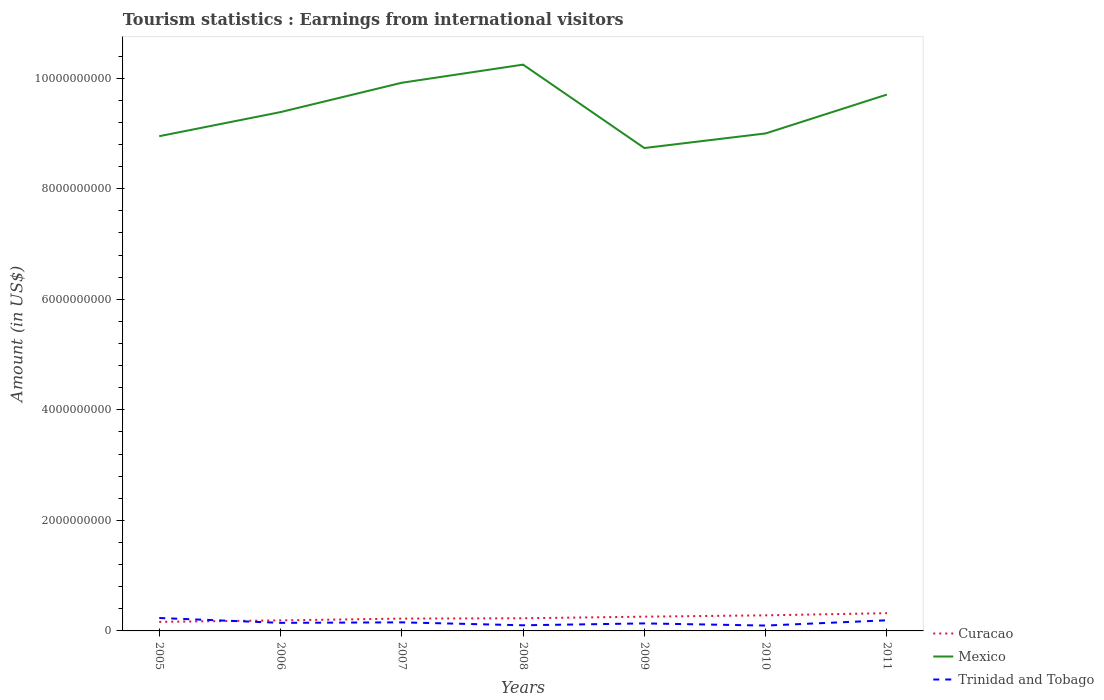Across all years, what is the maximum earnings from international visitors in Trinidad and Tobago?
Provide a succinct answer. 9.70e+07. What is the total earnings from international visitors in Curacao in the graph?
Your answer should be very brief. -9.20e+07. What is the difference between the highest and the second highest earnings from international visitors in Trinidad and Tobago?
Ensure brevity in your answer.  1.37e+08. What is the difference between the highest and the lowest earnings from international visitors in Trinidad and Tobago?
Provide a short and direct response. 3. What is the difference between two consecutive major ticks on the Y-axis?
Provide a succinct answer. 2.00e+09. Does the graph contain any zero values?
Provide a succinct answer. No. How many legend labels are there?
Make the answer very short. 3. How are the legend labels stacked?
Make the answer very short. Vertical. What is the title of the graph?
Your answer should be compact. Tourism statistics : Earnings from international visitors. Does "Sierra Leone" appear as one of the legend labels in the graph?
Make the answer very short. No. What is the label or title of the X-axis?
Offer a very short reply. Years. What is the label or title of the Y-axis?
Offer a terse response. Amount (in US$). What is the Amount (in US$) in Curacao in 2005?
Provide a succinct answer. 1.64e+08. What is the Amount (in US$) in Mexico in 2005?
Make the answer very short. 8.95e+09. What is the Amount (in US$) in Trinidad and Tobago in 2005?
Provide a short and direct response. 2.34e+08. What is the Amount (in US$) of Curacao in 2006?
Your answer should be compact. 1.91e+08. What is the Amount (in US$) in Mexico in 2006?
Your response must be concise. 9.39e+09. What is the Amount (in US$) in Trinidad and Tobago in 2006?
Offer a terse response. 1.46e+08. What is the Amount (in US$) in Curacao in 2007?
Keep it short and to the point. 2.23e+08. What is the Amount (in US$) of Mexico in 2007?
Your answer should be very brief. 9.92e+09. What is the Amount (in US$) of Trinidad and Tobago in 2007?
Your answer should be very brief. 1.55e+08. What is the Amount (in US$) of Curacao in 2008?
Offer a terse response. 2.29e+08. What is the Amount (in US$) of Mexico in 2008?
Offer a very short reply. 1.02e+1. What is the Amount (in US$) in Trinidad and Tobago in 2008?
Your response must be concise. 1.02e+08. What is the Amount (in US$) in Curacao in 2009?
Your answer should be compact. 2.58e+08. What is the Amount (in US$) of Mexico in 2009?
Provide a succinct answer. 8.74e+09. What is the Amount (in US$) of Trinidad and Tobago in 2009?
Offer a very short reply. 1.36e+08. What is the Amount (in US$) of Curacao in 2010?
Your answer should be very brief. 2.82e+08. What is the Amount (in US$) in Mexico in 2010?
Make the answer very short. 9.00e+09. What is the Amount (in US$) of Trinidad and Tobago in 2010?
Make the answer very short. 9.70e+07. What is the Amount (in US$) in Curacao in 2011?
Ensure brevity in your answer.  3.21e+08. What is the Amount (in US$) in Mexico in 2011?
Keep it short and to the point. 9.70e+09. What is the Amount (in US$) in Trinidad and Tobago in 2011?
Your answer should be compact. 1.92e+08. Across all years, what is the maximum Amount (in US$) in Curacao?
Offer a terse response. 3.21e+08. Across all years, what is the maximum Amount (in US$) of Mexico?
Make the answer very short. 1.02e+1. Across all years, what is the maximum Amount (in US$) of Trinidad and Tobago?
Keep it short and to the point. 2.34e+08. Across all years, what is the minimum Amount (in US$) in Curacao?
Offer a terse response. 1.64e+08. Across all years, what is the minimum Amount (in US$) of Mexico?
Provide a short and direct response. 8.74e+09. Across all years, what is the minimum Amount (in US$) of Trinidad and Tobago?
Offer a very short reply. 9.70e+07. What is the total Amount (in US$) in Curacao in the graph?
Ensure brevity in your answer.  1.67e+09. What is the total Amount (in US$) in Mexico in the graph?
Offer a very short reply. 6.59e+1. What is the total Amount (in US$) of Trinidad and Tobago in the graph?
Your answer should be compact. 1.06e+09. What is the difference between the Amount (in US$) in Curacao in 2005 and that in 2006?
Provide a succinct answer. -2.70e+07. What is the difference between the Amount (in US$) in Mexico in 2005 and that in 2006?
Your response must be concise. -4.36e+08. What is the difference between the Amount (in US$) of Trinidad and Tobago in 2005 and that in 2006?
Provide a short and direct response. 8.80e+07. What is the difference between the Amount (in US$) of Curacao in 2005 and that in 2007?
Your response must be concise. -5.90e+07. What is the difference between the Amount (in US$) of Mexico in 2005 and that in 2007?
Your answer should be very brief. -9.67e+08. What is the difference between the Amount (in US$) in Trinidad and Tobago in 2005 and that in 2007?
Provide a short and direct response. 7.90e+07. What is the difference between the Amount (in US$) of Curacao in 2005 and that in 2008?
Provide a short and direct response. -6.50e+07. What is the difference between the Amount (in US$) of Mexico in 2005 and that in 2008?
Keep it short and to the point. -1.30e+09. What is the difference between the Amount (in US$) of Trinidad and Tobago in 2005 and that in 2008?
Give a very brief answer. 1.32e+08. What is the difference between the Amount (in US$) of Curacao in 2005 and that in 2009?
Provide a short and direct response. -9.40e+07. What is the difference between the Amount (in US$) in Mexico in 2005 and that in 2009?
Offer a terse response. 2.14e+08. What is the difference between the Amount (in US$) of Trinidad and Tobago in 2005 and that in 2009?
Provide a succinct answer. 9.80e+07. What is the difference between the Amount (in US$) of Curacao in 2005 and that in 2010?
Keep it short and to the point. -1.18e+08. What is the difference between the Amount (in US$) of Mexico in 2005 and that in 2010?
Provide a short and direct response. -5.00e+07. What is the difference between the Amount (in US$) in Trinidad and Tobago in 2005 and that in 2010?
Offer a very short reply. 1.37e+08. What is the difference between the Amount (in US$) of Curacao in 2005 and that in 2011?
Ensure brevity in your answer.  -1.57e+08. What is the difference between the Amount (in US$) of Mexico in 2005 and that in 2011?
Ensure brevity in your answer.  -7.53e+08. What is the difference between the Amount (in US$) of Trinidad and Tobago in 2005 and that in 2011?
Offer a very short reply. 4.20e+07. What is the difference between the Amount (in US$) of Curacao in 2006 and that in 2007?
Your response must be concise. -3.20e+07. What is the difference between the Amount (in US$) in Mexico in 2006 and that in 2007?
Offer a very short reply. -5.31e+08. What is the difference between the Amount (in US$) of Trinidad and Tobago in 2006 and that in 2007?
Make the answer very short. -9.00e+06. What is the difference between the Amount (in US$) of Curacao in 2006 and that in 2008?
Ensure brevity in your answer.  -3.80e+07. What is the difference between the Amount (in US$) of Mexico in 2006 and that in 2008?
Give a very brief answer. -8.59e+08. What is the difference between the Amount (in US$) in Trinidad and Tobago in 2006 and that in 2008?
Offer a terse response. 4.40e+07. What is the difference between the Amount (in US$) in Curacao in 2006 and that in 2009?
Provide a short and direct response. -6.70e+07. What is the difference between the Amount (in US$) of Mexico in 2006 and that in 2009?
Your answer should be compact. 6.50e+08. What is the difference between the Amount (in US$) of Curacao in 2006 and that in 2010?
Provide a succinct answer. -9.10e+07. What is the difference between the Amount (in US$) in Mexico in 2006 and that in 2010?
Make the answer very short. 3.86e+08. What is the difference between the Amount (in US$) in Trinidad and Tobago in 2006 and that in 2010?
Your answer should be compact. 4.90e+07. What is the difference between the Amount (in US$) of Curacao in 2006 and that in 2011?
Your answer should be very brief. -1.30e+08. What is the difference between the Amount (in US$) in Mexico in 2006 and that in 2011?
Offer a terse response. -3.17e+08. What is the difference between the Amount (in US$) in Trinidad and Tobago in 2006 and that in 2011?
Ensure brevity in your answer.  -4.60e+07. What is the difference between the Amount (in US$) of Curacao in 2007 and that in 2008?
Your response must be concise. -6.00e+06. What is the difference between the Amount (in US$) in Mexico in 2007 and that in 2008?
Ensure brevity in your answer.  -3.28e+08. What is the difference between the Amount (in US$) in Trinidad and Tobago in 2007 and that in 2008?
Your answer should be compact. 5.30e+07. What is the difference between the Amount (in US$) of Curacao in 2007 and that in 2009?
Your answer should be compact. -3.50e+07. What is the difference between the Amount (in US$) in Mexico in 2007 and that in 2009?
Offer a very short reply. 1.18e+09. What is the difference between the Amount (in US$) in Trinidad and Tobago in 2007 and that in 2009?
Make the answer very short. 1.90e+07. What is the difference between the Amount (in US$) in Curacao in 2007 and that in 2010?
Make the answer very short. -5.90e+07. What is the difference between the Amount (in US$) in Mexico in 2007 and that in 2010?
Give a very brief answer. 9.17e+08. What is the difference between the Amount (in US$) of Trinidad and Tobago in 2007 and that in 2010?
Provide a succinct answer. 5.80e+07. What is the difference between the Amount (in US$) in Curacao in 2007 and that in 2011?
Offer a terse response. -9.80e+07. What is the difference between the Amount (in US$) in Mexico in 2007 and that in 2011?
Keep it short and to the point. 2.14e+08. What is the difference between the Amount (in US$) of Trinidad and Tobago in 2007 and that in 2011?
Give a very brief answer. -3.70e+07. What is the difference between the Amount (in US$) in Curacao in 2008 and that in 2009?
Make the answer very short. -2.90e+07. What is the difference between the Amount (in US$) of Mexico in 2008 and that in 2009?
Your answer should be very brief. 1.51e+09. What is the difference between the Amount (in US$) in Trinidad and Tobago in 2008 and that in 2009?
Offer a very short reply. -3.40e+07. What is the difference between the Amount (in US$) in Curacao in 2008 and that in 2010?
Keep it short and to the point. -5.30e+07. What is the difference between the Amount (in US$) of Mexico in 2008 and that in 2010?
Provide a short and direct response. 1.24e+09. What is the difference between the Amount (in US$) of Trinidad and Tobago in 2008 and that in 2010?
Ensure brevity in your answer.  5.00e+06. What is the difference between the Amount (in US$) of Curacao in 2008 and that in 2011?
Your answer should be very brief. -9.20e+07. What is the difference between the Amount (in US$) in Mexico in 2008 and that in 2011?
Your response must be concise. 5.42e+08. What is the difference between the Amount (in US$) in Trinidad and Tobago in 2008 and that in 2011?
Keep it short and to the point. -9.00e+07. What is the difference between the Amount (in US$) in Curacao in 2009 and that in 2010?
Ensure brevity in your answer.  -2.40e+07. What is the difference between the Amount (in US$) in Mexico in 2009 and that in 2010?
Keep it short and to the point. -2.64e+08. What is the difference between the Amount (in US$) of Trinidad and Tobago in 2009 and that in 2010?
Your answer should be very brief. 3.90e+07. What is the difference between the Amount (in US$) of Curacao in 2009 and that in 2011?
Ensure brevity in your answer.  -6.30e+07. What is the difference between the Amount (in US$) in Mexico in 2009 and that in 2011?
Provide a short and direct response. -9.67e+08. What is the difference between the Amount (in US$) in Trinidad and Tobago in 2009 and that in 2011?
Offer a very short reply. -5.60e+07. What is the difference between the Amount (in US$) in Curacao in 2010 and that in 2011?
Keep it short and to the point. -3.90e+07. What is the difference between the Amount (in US$) of Mexico in 2010 and that in 2011?
Ensure brevity in your answer.  -7.03e+08. What is the difference between the Amount (in US$) of Trinidad and Tobago in 2010 and that in 2011?
Your answer should be compact. -9.50e+07. What is the difference between the Amount (in US$) of Curacao in 2005 and the Amount (in US$) of Mexico in 2006?
Your response must be concise. -9.22e+09. What is the difference between the Amount (in US$) of Curacao in 2005 and the Amount (in US$) of Trinidad and Tobago in 2006?
Your answer should be very brief. 1.80e+07. What is the difference between the Amount (in US$) of Mexico in 2005 and the Amount (in US$) of Trinidad and Tobago in 2006?
Make the answer very short. 8.80e+09. What is the difference between the Amount (in US$) in Curacao in 2005 and the Amount (in US$) in Mexico in 2007?
Provide a short and direct response. -9.75e+09. What is the difference between the Amount (in US$) in Curacao in 2005 and the Amount (in US$) in Trinidad and Tobago in 2007?
Make the answer very short. 9.00e+06. What is the difference between the Amount (in US$) of Mexico in 2005 and the Amount (in US$) of Trinidad and Tobago in 2007?
Keep it short and to the point. 8.80e+09. What is the difference between the Amount (in US$) of Curacao in 2005 and the Amount (in US$) of Mexico in 2008?
Ensure brevity in your answer.  -1.01e+1. What is the difference between the Amount (in US$) in Curacao in 2005 and the Amount (in US$) in Trinidad and Tobago in 2008?
Give a very brief answer. 6.20e+07. What is the difference between the Amount (in US$) in Mexico in 2005 and the Amount (in US$) in Trinidad and Tobago in 2008?
Make the answer very short. 8.85e+09. What is the difference between the Amount (in US$) of Curacao in 2005 and the Amount (in US$) of Mexico in 2009?
Keep it short and to the point. -8.57e+09. What is the difference between the Amount (in US$) in Curacao in 2005 and the Amount (in US$) in Trinidad and Tobago in 2009?
Offer a terse response. 2.80e+07. What is the difference between the Amount (in US$) of Mexico in 2005 and the Amount (in US$) of Trinidad and Tobago in 2009?
Give a very brief answer. 8.82e+09. What is the difference between the Amount (in US$) in Curacao in 2005 and the Amount (in US$) in Mexico in 2010?
Give a very brief answer. -8.84e+09. What is the difference between the Amount (in US$) of Curacao in 2005 and the Amount (in US$) of Trinidad and Tobago in 2010?
Offer a terse response. 6.70e+07. What is the difference between the Amount (in US$) in Mexico in 2005 and the Amount (in US$) in Trinidad and Tobago in 2010?
Provide a short and direct response. 8.85e+09. What is the difference between the Amount (in US$) in Curacao in 2005 and the Amount (in US$) in Mexico in 2011?
Make the answer very short. -9.54e+09. What is the difference between the Amount (in US$) in Curacao in 2005 and the Amount (in US$) in Trinidad and Tobago in 2011?
Your answer should be compact. -2.80e+07. What is the difference between the Amount (in US$) in Mexico in 2005 and the Amount (in US$) in Trinidad and Tobago in 2011?
Keep it short and to the point. 8.76e+09. What is the difference between the Amount (in US$) in Curacao in 2006 and the Amount (in US$) in Mexico in 2007?
Offer a very short reply. -9.73e+09. What is the difference between the Amount (in US$) of Curacao in 2006 and the Amount (in US$) of Trinidad and Tobago in 2007?
Make the answer very short. 3.60e+07. What is the difference between the Amount (in US$) in Mexico in 2006 and the Amount (in US$) in Trinidad and Tobago in 2007?
Ensure brevity in your answer.  9.23e+09. What is the difference between the Amount (in US$) of Curacao in 2006 and the Amount (in US$) of Mexico in 2008?
Offer a very short reply. -1.01e+1. What is the difference between the Amount (in US$) of Curacao in 2006 and the Amount (in US$) of Trinidad and Tobago in 2008?
Give a very brief answer. 8.90e+07. What is the difference between the Amount (in US$) of Mexico in 2006 and the Amount (in US$) of Trinidad and Tobago in 2008?
Make the answer very short. 9.28e+09. What is the difference between the Amount (in US$) of Curacao in 2006 and the Amount (in US$) of Mexico in 2009?
Ensure brevity in your answer.  -8.55e+09. What is the difference between the Amount (in US$) in Curacao in 2006 and the Amount (in US$) in Trinidad and Tobago in 2009?
Your answer should be compact. 5.50e+07. What is the difference between the Amount (in US$) of Mexico in 2006 and the Amount (in US$) of Trinidad and Tobago in 2009?
Your response must be concise. 9.25e+09. What is the difference between the Amount (in US$) of Curacao in 2006 and the Amount (in US$) of Mexico in 2010?
Offer a very short reply. -8.81e+09. What is the difference between the Amount (in US$) in Curacao in 2006 and the Amount (in US$) in Trinidad and Tobago in 2010?
Your answer should be very brief. 9.40e+07. What is the difference between the Amount (in US$) of Mexico in 2006 and the Amount (in US$) of Trinidad and Tobago in 2010?
Your answer should be compact. 9.29e+09. What is the difference between the Amount (in US$) of Curacao in 2006 and the Amount (in US$) of Mexico in 2011?
Your answer should be very brief. -9.51e+09. What is the difference between the Amount (in US$) in Curacao in 2006 and the Amount (in US$) in Trinidad and Tobago in 2011?
Make the answer very short. -1.00e+06. What is the difference between the Amount (in US$) in Mexico in 2006 and the Amount (in US$) in Trinidad and Tobago in 2011?
Make the answer very short. 9.20e+09. What is the difference between the Amount (in US$) of Curacao in 2007 and the Amount (in US$) of Mexico in 2008?
Your response must be concise. -1.00e+1. What is the difference between the Amount (in US$) in Curacao in 2007 and the Amount (in US$) in Trinidad and Tobago in 2008?
Offer a very short reply. 1.21e+08. What is the difference between the Amount (in US$) of Mexico in 2007 and the Amount (in US$) of Trinidad and Tobago in 2008?
Give a very brief answer. 9.82e+09. What is the difference between the Amount (in US$) of Curacao in 2007 and the Amount (in US$) of Mexico in 2009?
Provide a succinct answer. -8.51e+09. What is the difference between the Amount (in US$) in Curacao in 2007 and the Amount (in US$) in Trinidad and Tobago in 2009?
Offer a very short reply. 8.70e+07. What is the difference between the Amount (in US$) in Mexico in 2007 and the Amount (in US$) in Trinidad and Tobago in 2009?
Make the answer very short. 9.78e+09. What is the difference between the Amount (in US$) in Curacao in 2007 and the Amount (in US$) in Mexico in 2010?
Your answer should be very brief. -8.78e+09. What is the difference between the Amount (in US$) in Curacao in 2007 and the Amount (in US$) in Trinidad and Tobago in 2010?
Provide a short and direct response. 1.26e+08. What is the difference between the Amount (in US$) of Mexico in 2007 and the Amount (in US$) of Trinidad and Tobago in 2010?
Provide a succinct answer. 9.82e+09. What is the difference between the Amount (in US$) of Curacao in 2007 and the Amount (in US$) of Mexico in 2011?
Ensure brevity in your answer.  -9.48e+09. What is the difference between the Amount (in US$) of Curacao in 2007 and the Amount (in US$) of Trinidad and Tobago in 2011?
Your response must be concise. 3.10e+07. What is the difference between the Amount (in US$) in Mexico in 2007 and the Amount (in US$) in Trinidad and Tobago in 2011?
Offer a very short reply. 9.73e+09. What is the difference between the Amount (in US$) of Curacao in 2008 and the Amount (in US$) of Mexico in 2009?
Keep it short and to the point. -8.51e+09. What is the difference between the Amount (in US$) of Curacao in 2008 and the Amount (in US$) of Trinidad and Tobago in 2009?
Your answer should be compact. 9.30e+07. What is the difference between the Amount (in US$) in Mexico in 2008 and the Amount (in US$) in Trinidad and Tobago in 2009?
Keep it short and to the point. 1.01e+1. What is the difference between the Amount (in US$) of Curacao in 2008 and the Amount (in US$) of Mexico in 2010?
Make the answer very short. -8.77e+09. What is the difference between the Amount (in US$) in Curacao in 2008 and the Amount (in US$) in Trinidad and Tobago in 2010?
Offer a terse response. 1.32e+08. What is the difference between the Amount (in US$) of Mexico in 2008 and the Amount (in US$) of Trinidad and Tobago in 2010?
Your response must be concise. 1.01e+1. What is the difference between the Amount (in US$) of Curacao in 2008 and the Amount (in US$) of Mexico in 2011?
Give a very brief answer. -9.48e+09. What is the difference between the Amount (in US$) of Curacao in 2008 and the Amount (in US$) of Trinidad and Tobago in 2011?
Provide a succinct answer. 3.70e+07. What is the difference between the Amount (in US$) of Mexico in 2008 and the Amount (in US$) of Trinidad and Tobago in 2011?
Offer a very short reply. 1.01e+1. What is the difference between the Amount (in US$) in Curacao in 2009 and the Amount (in US$) in Mexico in 2010?
Provide a short and direct response. -8.74e+09. What is the difference between the Amount (in US$) in Curacao in 2009 and the Amount (in US$) in Trinidad and Tobago in 2010?
Your response must be concise. 1.61e+08. What is the difference between the Amount (in US$) of Mexico in 2009 and the Amount (in US$) of Trinidad and Tobago in 2010?
Keep it short and to the point. 8.64e+09. What is the difference between the Amount (in US$) of Curacao in 2009 and the Amount (in US$) of Mexico in 2011?
Provide a short and direct response. -9.45e+09. What is the difference between the Amount (in US$) of Curacao in 2009 and the Amount (in US$) of Trinidad and Tobago in 2011?
Provide a succinct answer. 6.60e+07. What is the difference between the Amount (in US$) in Mexico in 2009 and the Amount (in US$) in Trinidad and Tobago in 2011?
Offer a very short reply. 8.54e+09. What is the difference between the Amount (in US$) in Curacao in 2010 and the Amount (in US$) in Mexico in 2011?
Your response must be concise. -9.42e+09. What is the difference between the Amount (in US$) in Curacao in 2010 and the Amount (in US$) in Trinidad and Tobago in 2011?
Your answer should be very brief. 9.00e+07. What is the difference between the Amount (in US$) of Mexico in 2010 and the Amount (in US$) of Trinidad and Tobago in 2011?
Make the answer very short. 8.81e+09. What is the average Amount (in US$) in Curacao per year?
Offer a terse response. 2.38e+08. What is the average Amount (in US$) in Mexico per year?
Offer a terse response. 9.42e+09. What is the average Amount (in US$) of Trinidad and Tobago per year?
Provide a short and direct response. 1.52e+08. In the year 2005, what is the difference between the Amount (in US$) of Curacao and Amount (in US$) of Mexico?
Keep it short and to the point. -8.79e+09. In the year 2005, what is the difference between the Amount (in US$) of Curacao and Amount (in US$) of Trinidad and Tobago?
Make the answer very short. -7.00e+07. In the year 2005, what is the difference between the Amount (in US$) in Mexico and Amount (in US$) in Trinidad and Tobago?
Provide a succinct answer. 8.72e+09. In the year 2006, what is the difference between the Amount (in US$) in Curacao and Amount (in US$) in Mexico?
Provide a succinct answer. -9.20e+09. In the year 2006, what is the difference between the Amount (in US$) in Curacao and Amount (in US$) in Trinidad and Tobago?
Offer a very short reply. 4.50e+07. In the year 2006, what is the difference between the Amount (in US$) of Mexico and Amount (in US$) of Trinidad and Tobago?
Offer a very short reply. 9.24e+09. In the year 2007, what is the difference between the Amount (in US$) of Curacao and Amount (in US$) of Mexico?
Provide a short and direct response. -9.70e+09. In the year 2007, what is the difference between the Amount (in US$) of Curacao and Amount (in US$) of Trinidad and Tobago?
Provide a succinct answer. 6.80e+07. In the year 2007, what is the difference between the Amount (in US$) in Mexico and Amount (in US$) in Trinidad and Tobago?
Keep it short and to the point. 9.76e+09. In the year 2008, what is the difference between the Amount (in US$) of Curacao and Amount (in US$) of Mexico?
Give a very brief answer. -1.00e+1. In the year 2008, what is the difference between the Amount (in US$) in Curacao and Amount (in US$) in Trinidad and Tobago?
Your answer should be very brief. 1.27e+08. In the year 2008, what is the difference between the Amount (in US$) in Mexico and Amount (in US$) in Trinidad and Tobago?
Give a very brief answer. 1.01e+1. In the year 2009, what is the difference between the Amount (in US$) of Curacao and Amount (in US$) of Mexico?
Make the answer very short. -8.48e+09. In the year 2009, what is the difference between the Amount (in US$) in Curacao and Amount (in US$) in Trinidad and Tobago?
Give a very brief answer. 1.22e+08. In the year 2009, what is the difference between the Amount (in US$) of Mexico and Amount (in US$) of Trinidad and Tobago?
Ensure brevity in your answer.  8.60e+09. In the year 2010, what is the difference between the Amount (in US$) in Curacao and Amount (in US$) in Mexico?
Give a very brief answer. -8.72e+09. In the year 2010, what is the difference between the Amount (in US$) in Curacao and Amount (in US$) in Trinidad and Tobago?
Offer a very short reply. 1.85e+08. In the year 2010, what is the difference between the Amount (in US$) of Mexico and Amount (in US$) of Trinidad and Tobago?
Provide a succinct answer. 8.90e+09. In the year 2011, what is the difference between the Amount (in US$) in Curacao and Amount (in US$) in Mexico?
Provide a short and direct response. -9.38e+09. In the year 2011, what is the difference between the Amount (in US$) of Curacao and Amount (in US$) of Trinidad and Tobago?
Ensure brevity in your answer.  1.29e+08. In the year 2011, what is the difference between the Amount (in US$) of Mexico and Amount (in US$) of Trinidad and Tobago?
Provide a short and direct response. 9.51e+09. What is the ratio of the Amount (in US$) of Curacao in 2005 to that in 2006?
Make the answer very short. 0.86. What is the ratio of the Amount (in US$) in Mexico in 2005 to that in 2006?
Give a very brief answer. 0.95. What is the ratio of the Amount (in US$) in Trinidad and Tobago in 2005 to that in 2006?
Your answer should be compact. 1.6. What is the ratio of the Amount (in US$) in Curacao in 2005 to that in 2007?
Keep it short and to the point. 0.74. What is the ratio of the Amount (in US$) of Mexico in 2005 to that in 2007?
Provide a succinct answer. 0.9. What is the ratio of the Amount (in US$) of Trinidad and Tobago in 2005 to that in 2007?
Provide a succinct answer. 1.51. What is the ratio of the Amount (in US$) of Curacao in 2005 to that in 2008?
Keep it short and to the point. 0.72. What is the ratio of the Amount (in US$) of Mexico in 2005 to that in 2008?
Provide a succinct answer. 0.87. What is the ratio of the Amount (in US$) of Trinidad and Tobago in 2005 to that in 2008?
Offer a terse response. 2.29. What is the ratio of the Amount (in US$) of Curacao in 2005 to that in 2009?
Offer a terse response. 0.64. What is the ratio of the Amount (in US$) of Mexico in 2005 to that in 2009?
Ensure brevity in your answer.  1.02. What is the ratio of the Amount (in US$) of Trinidad and Tobago in 2005 to that in 2009?
Make the answer very short. 1.72. What is the ratio of the Amount (in US$) of Curacao in 2005 to that in 2010?
Ensure brevity in your answer.  0.58. What is the ratio of the Amount (in US$) in Trinidad and Tobago in 2005 to that in 2010?
Give a very brief answer. 2.41. What is the ratio of the Amount (in US$) of Curacao in 2005 to that in 2011?
Make the answer very short. 0.51. What is the ratio of the Amount (in US$) of Mexico in 2005 to that in 2011?
Provide a short and direct response. 0.92. What is the ratio of the Amount (in US$) of Trinidad and Tobago in 2005 to that in 2011?
Make the answer very short. 1.22. What is the ratio of the Amount (in US$) in Curacao in 2006 to that in 2007?
Provide a short and direct response. 0.86. What is the ratio of the Amount (in US$) in Mexico in 2006 to that in 2007?
Provide a short and direct response. 0.95. What is the ratio of the Amount (in US$) in Trinidad and Tobago in 2006 to that in 2007?
Ensure brevity in your answer.  0.94. What is the ratio of the Amount (in US$) of Curacao in 2006 to that in 2008?
Give a very brief answer. 0.83. What is the ratio of the Amount (in US$) of Mexico in 2006 to that in 2008?
Provide a succinct answer. 0.92. What is the ratio of the Amount (in US$) of Trinidad and Tobago in 2006 to that in 2008?
Give a very brief answer. 1.43. What is the ratio of the Amount (in US$) of Curacao in 2006 to that in 2009?
Offer a terse response. 0.74. What is the ratio of the Amount (in US$) of Mexico in 2006 to that in 2009?
Your answer should be very brief. 1.07. What is the ratio of the Amount (in US$) in Trinidad and Tobago in 2006 to that in 2009?
Ensure brevity in your answer.  1.07. What is the ratio of the Amount (in US$) in Curacao in 2006 to that in 2010?
Provide a short and direct response. 0.68. What is the ratio of the Amount (in US$) in Mexico in 2006 to that in 2010?
Give a very brief answer. 1.04. What is the ratio of the Amount (in US$) of Trinidad and Tobago in 2006 to that in 2010?
Your answer should be compact. 1.51. What is the ratio of the Amount (in US$) of Curacao in 2006 to that in 2011?
Your answer should be very brief. 0.59. What is the ratio of the Amount (in US$) of Mexico in 2006 to that in 2011?
Your answer should be compact. 0.97. What is the ratio of the Amount (in US$) in Trinidad and Tobago in 2006 to that in 2011?
Your response must be concise. 0.76. What is the ratio of the Amount (in US$) of Curacao in 2007 to that in 2008?
Your answer should be very brief. 0.97. What is the ratio of the Amount (in US$) in Trinidad and Tobago in 2007 to that in 2008?
Give a very brief answer. 1.52. What is the ratio of the Amount (in US$) in Curacao in 2007 to that in 2009?
Your response must be concise. 0.86. What is the ratio of the Amount (in US$) in Mexico in 2007 to that in 2009?
Give a very brief answer. 1.14. What is the ratio of the Amount (in US$) in Trinidad and Tobago in 2007 to that in 2009?
Keep it short and to the point. 1.14. What is the ratio of the Amount (in US$) of Curacao in 2007 to that in 2010?
Make the answer very short. 0.79. What is the ratio of the Amount (in US$) of Mexico in 2007 to that in 2010?
Keep it short and to the point. 1.1. What is the ratio of the Amount (in US$) in Trinidad and Tobago in 2007 to that in 2010?
Your answer should be compact. 1.6. What is the ratio of the Amount (in US$) in Curacao in 2007 to that in 2011?
Offer a terse response. 0.69. What is the ratio of the Amount (in US$) in Mexico in 2007 to that in 2011?
Provide a short and direct response. 1.02. What is the ratio of the Amount (in US$) of Trinidad and Tobago in 2007 to that in 2011?
Your answer should be compact. 0.81. What is the ratio of the Amount (in US$) of Curacao in 2008 to that in 2009?
Offer a terse response. 0.89. What is the ratio of the Amount (in US$) in Mexico in 2008 to that in 2009?
Make the answer very short. 1.17. What is the ratio of the Amount (in US$) in Trinidad and Tobago in 2008 to that in 2009?
Your response must be concise. 0.75. What is the ratio of the Amount (in US$) of Curacao in 2008 to that in 2010?
Keep it short and to the point. 0.81. What is the ratio of the Amount (in US$) of Mexico in 2008 to that in 2010?
Keep it short and to the point. 1.14. What is the ratio of the Amount (in US$) of Trinidad and Tobago in 2008 to that in 2010?
Provide a short and direct response. 1.05. What is the ratio of the Amount (in US$) of Curacao in 2008 to that in 2011?
Offer a terse response. 0.71. What is the ratio of the Amount (in US$) in Mexico in 2008 to that in 2011?
Provide a short and direct response. 1.06. What is the ratio of the Amount (in US$) of Trinidad and Tobago in 2008 to that in 2011?
Your answer should be very brief. 0.53. What is the ratio of the Amount (in US$) in Curacao in 2009 to that in 2010?
Your answer should be compact. 0.91. What is the ratio of the Amount (in US$) of Mexico in 2009 to that in 2010?
Offer a terse response. 0.97. What is the ratio of the Amount (in US$) in Trinidad and Tobago in 2009 to that in 2010?
Your response must be concise. 1.4. What is the ratio of the Amount (in US$) in Curacao in 2009 to that in 2011?
Your answer should be very brief. 0.8. What is the ratio of the Amount (in US$) of Mexico in 2009 to that in 2011?
Keep it short and to the point. 0.9. What is the ratio of the Amount (in US$) in Trinidad and Tobago in 2009 to that in 2011?
Your answer should be very brief. 0.71. What is the ratio of the Amount (in US$) in Curacao in 2010 to that in 2011?
Provide a succinct answer. 0.88. What is the ratio of the Amount (in US$) of Mexico in 2010 to that in 2011?
Give a very brief answer. 0.93. What is the ratio of the Amount (in US$) of Trinidad and Tobago in 2010 to that in 2011?
Provide a short and direct response. 0.51. What is the difference between the highest and the second highest Amount (in US$) in Curacao?
Your answer should be very brief. 3.90e+07. What is the difference between the highest and the second highest Amount (in US$) in Mexico?
Your response must be concise. 3.28e+08. What is the difference between the highest and the second highest Amount (in US$) of Trinidad and Tobago?
Give a very brief answer. 4.20e+07. What is the difference between the highest and the lowest Amount (in US$) in Curacao?
Offer a very short reply. 1.57e+08. What is the difference between the highest and the lowest Amount (in US$) of Mexico?
Offer a very short reply. 1.51e+09. What is the difference between the highest and the lowest Amount (in US$) of Trinidad and Tobago?
Ensure brevity in your answer.  1.37e+08. 